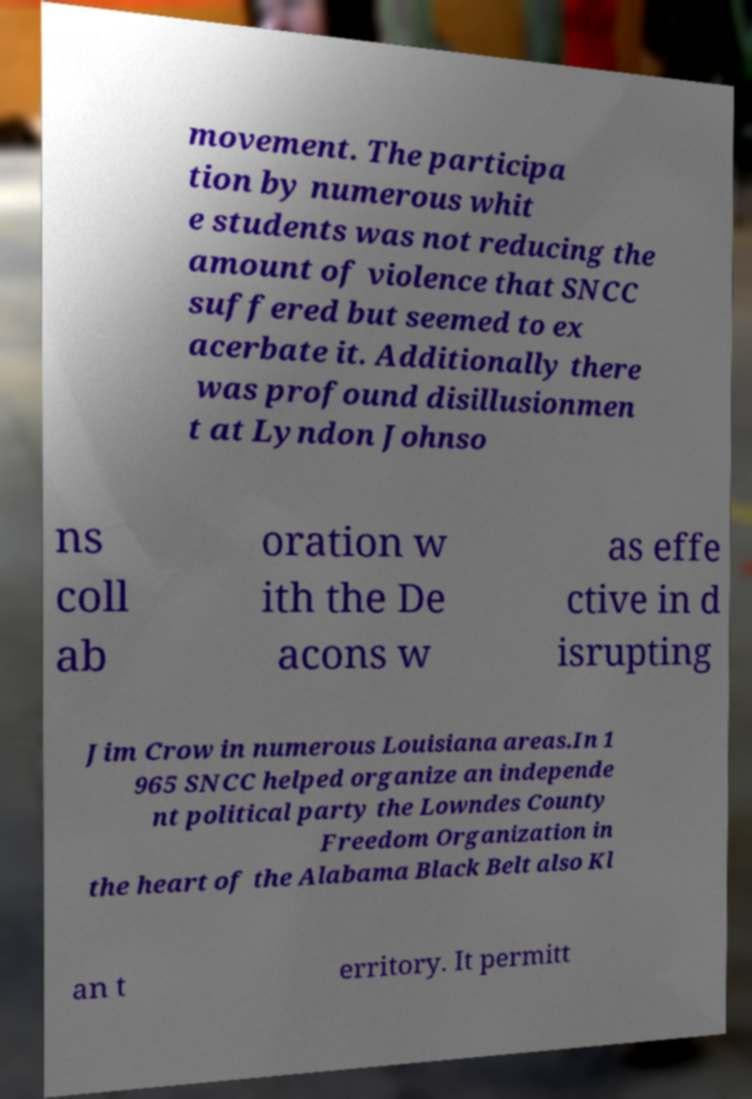For documentation purposes, I need the text within this image transcribed. Could you provide that? movement. The participa tion by numerous whit e students was not reducing the amount of violence that SNCC suffered but seemed to ex acerbate it. Additionally there was profound disillusionmen t at Lyndon Johnso ns coll ab oration w ith the De acons w as effe ctive in d isrupting Jim Crow in numerous Louisiana areas.In 1 965 SNCC helped organize an independe nt political party the Lowndes County Freedom Organization in the heart of the Alabama Black Belt also Kl an t erritory. It permitt 